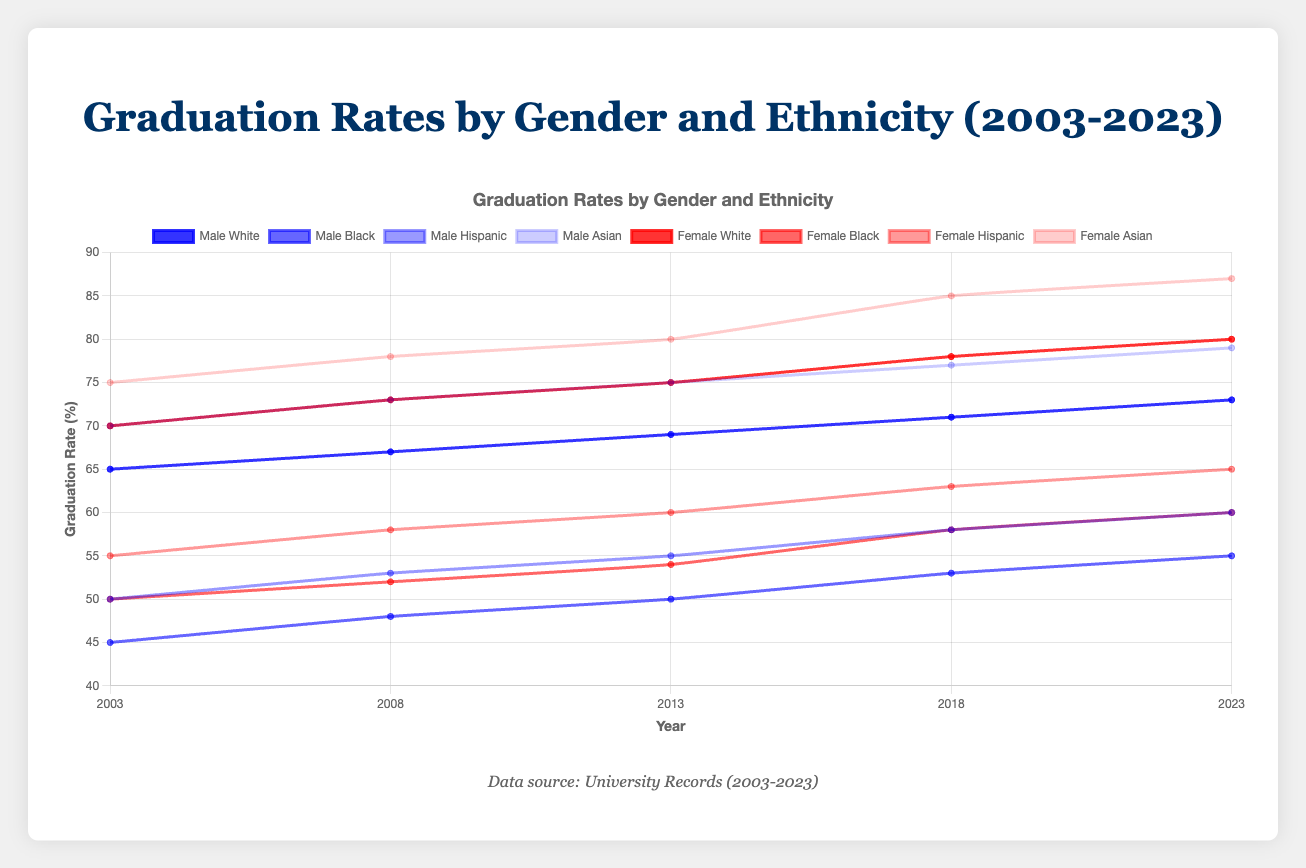What is the difference in graduation rates between Asian females and Black males in 2023? To find the difference, look at the graduation rate of Asian females in 2023 (87) and the graduation rate of Black males in 2023 (55). The difference is calculated as: 87 - 55.
Answer: 32 Which gender had a higher graduation rate for Hispanic students in 2018? In 2018, the graduation rate for Hispanic males was 58, and for Hispanic females, it was 63. Since 63 > 58, females had a higher graduation rate.
Answer: Female Between 2003 and 2023, which gender saw a larger increase in graduation rates for White students? In 2003, the graduation rate for White males was 65, and it increased to 73 by 2023. This is an increase of 8 (73 - 65). For White females, the rate went from 70 in 2003 to 80 in 2023, an increase of 10 (80 - 70).
Answer: Female What is the average graduation rate of Black students (both genders) in 2008? The graduation rates for Black males and females in 2008 are 48 and 52, respectively. The average is calculated by (48 + 52) / 2.
Answer: 50 Which group had the highest overall graduation rate in 2013? By checking all groups in 2013, Asian females had the highest rate at 80.
Answer: Asian females How did the graduation rate for Hispanic males change from 2003 to 2023? In 2003, the rate for Hispanic males was 50, and by 2023, it was 60. The change is calculated as 60 - 50.
Answer: Increased by 10 Compare the patterns of changes in graduation rates between Asian males and females over 20 years. Asian males' rates were: 70 (2003), 73 (2008), 75 (2013), 77 (2018), and 79 (2023). Asian females' rates were: 75 (2003), 78 (2008), 80 (2013), 85 (2018), and 87 (2023). Both show upward trends, but females have higher rates and steeper increases.
Answer: Both increased, females more What was the median graduation rate of all student groups in 2023? The 2023 graduation rates are: 73, 55, 60, 79, 80, 60, 65, and 87. After sorting: 55, 60, 60, 65, 73, 79, 80, and 87, the median is the middle value of an ordered list. If the list length is even, the median is the average of the two middle numbers. Here, (65+73)/2 = 69.
Answer: 69 Which gender had a smaller increase in graduation rates for Black students between 2003 and 2023? For Black males, the rate increased from 45 to 55, a change of 10 (55 - 45). For Black females, the rate increased from 50 to 60, a change of 10 (60 - 50). Since both changes are equal at 10, neither gender had a smaller increase.
Answer: Neither 